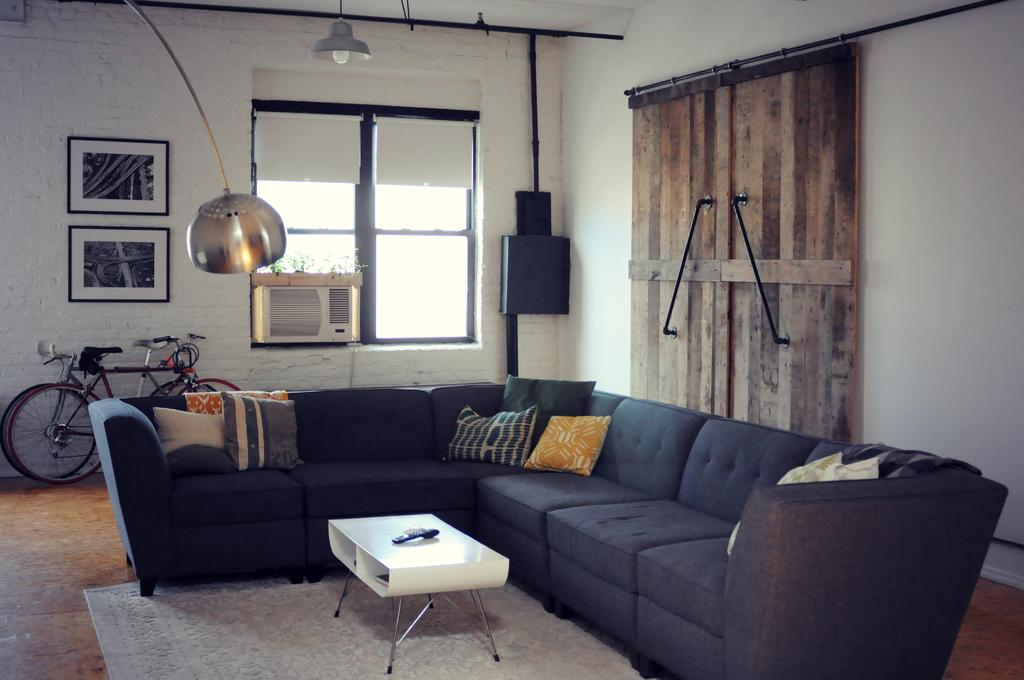What type of seating is present in the room? There is a sofa in the room. What is placed on the sofa? There are pillows on the sofa. What furniture is present in the room besides the sofa? There is a table in the room. What can be seen on the walls of the room? There are frames on the walls. What is the source of light in the room? There is a light fixture on the ceiling. What part of the room is visible? The floor is visible in the room. What type of disgusting waves can be seen crashing against the ground in the image? There are no waves or ground present in the image; it is an indoor room with a sofa, table, and other furniture. 